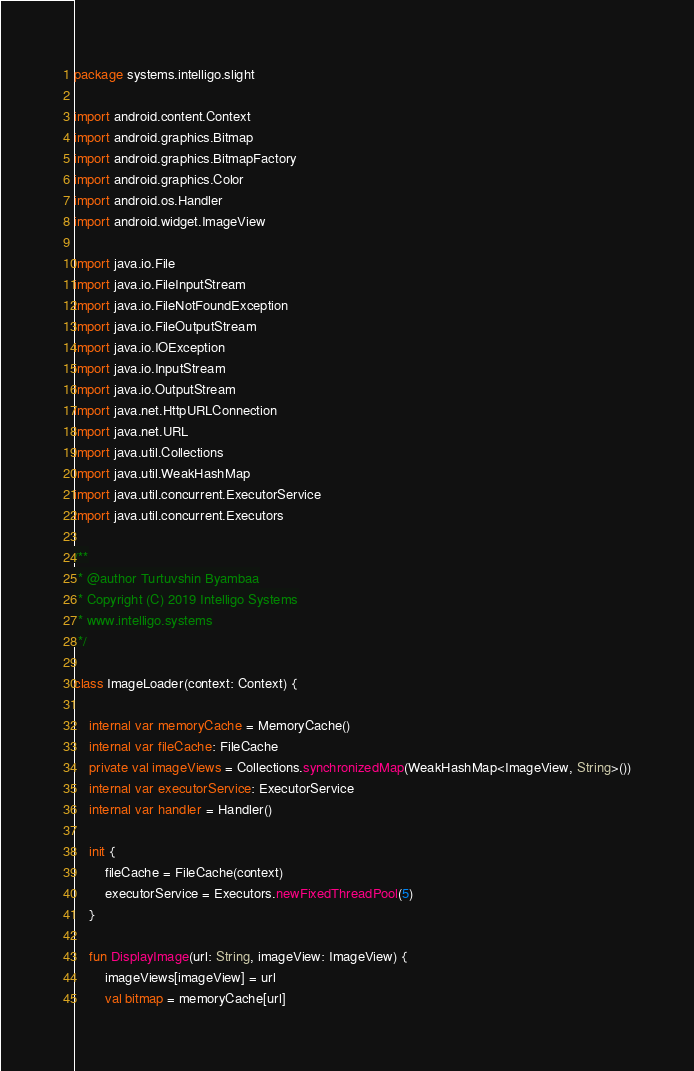<code> <loc_0><loc_0><loc_500><loc_500><_Kotlin_>package systems.intelligo.slight

import android.content.Context
import android.graphics.Bitmap
import android.graphics.BitmapFactory
import android.graphics.Color
import android.os.Handler
import android.widget.ImageView

import java.io.File
import java.io.FileInputStream
import java.io.FileNotFoundException
import java.io.FileOutputStream
import java.io.IOException
import java.io.InputStream
import java.io.OutputStream
import java.net.HttpURLConnection
import java.net.URL
import java.util.Collections
import java.util.WeakHashMap
import java.util.concurrent.ExecutorService
import java.util.concurrent.Executors

/**
 * @author Turtuvshin Byambaa
 * Copyright (C) 2019 Intelligo Systems
 * www.intelligo.systems
 */

class ImageLoader(context: Context) {

    internal var memoryCache = MemoryCache()
    internal var fileCache: FileCache
    private val imageViews = Collections.synchronizedMap(WeakHashMap<ImageView, String>())
    internal var executorService: ExecutorService
    internal var handler = Handler()

    init {
        fileCache = FileCache(context)
        executorService = Executors.newFixedThreadPool(5)
    }

    fun DisplayImage(url: String, imageView: ImageView) {
        imageViews[imageView] = url
        val bitmap = memoryCache[url]</code> 